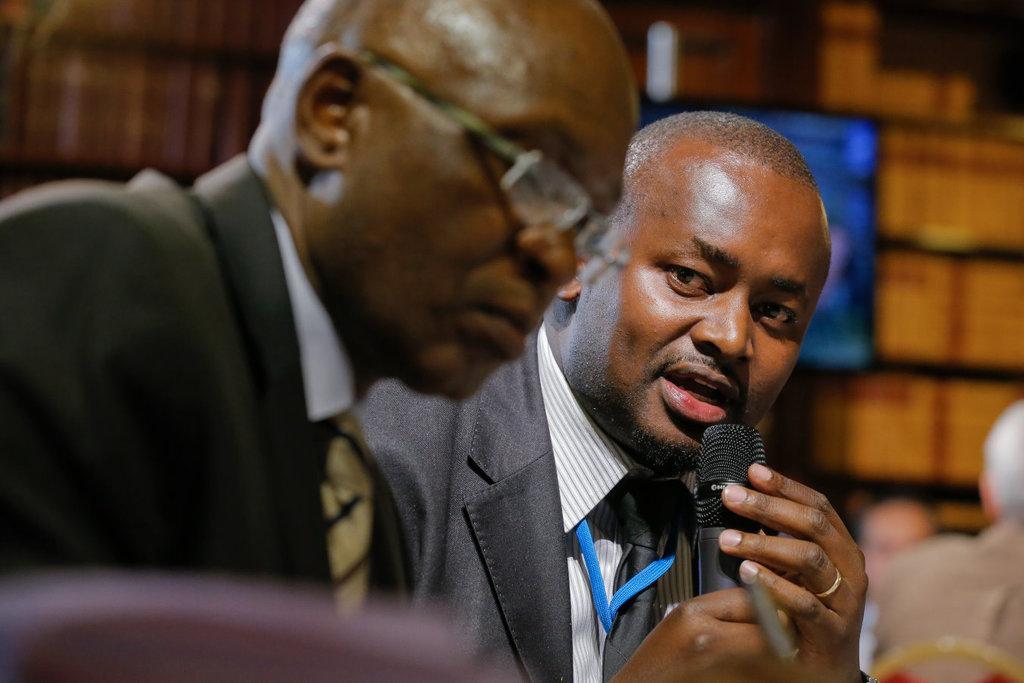In one or two sentences, can you explain what this image depicts? Here we can see two men in this picture, the person on the right side is speaking in the microphone present in his hand and behind him we can see people sitting on chairs 